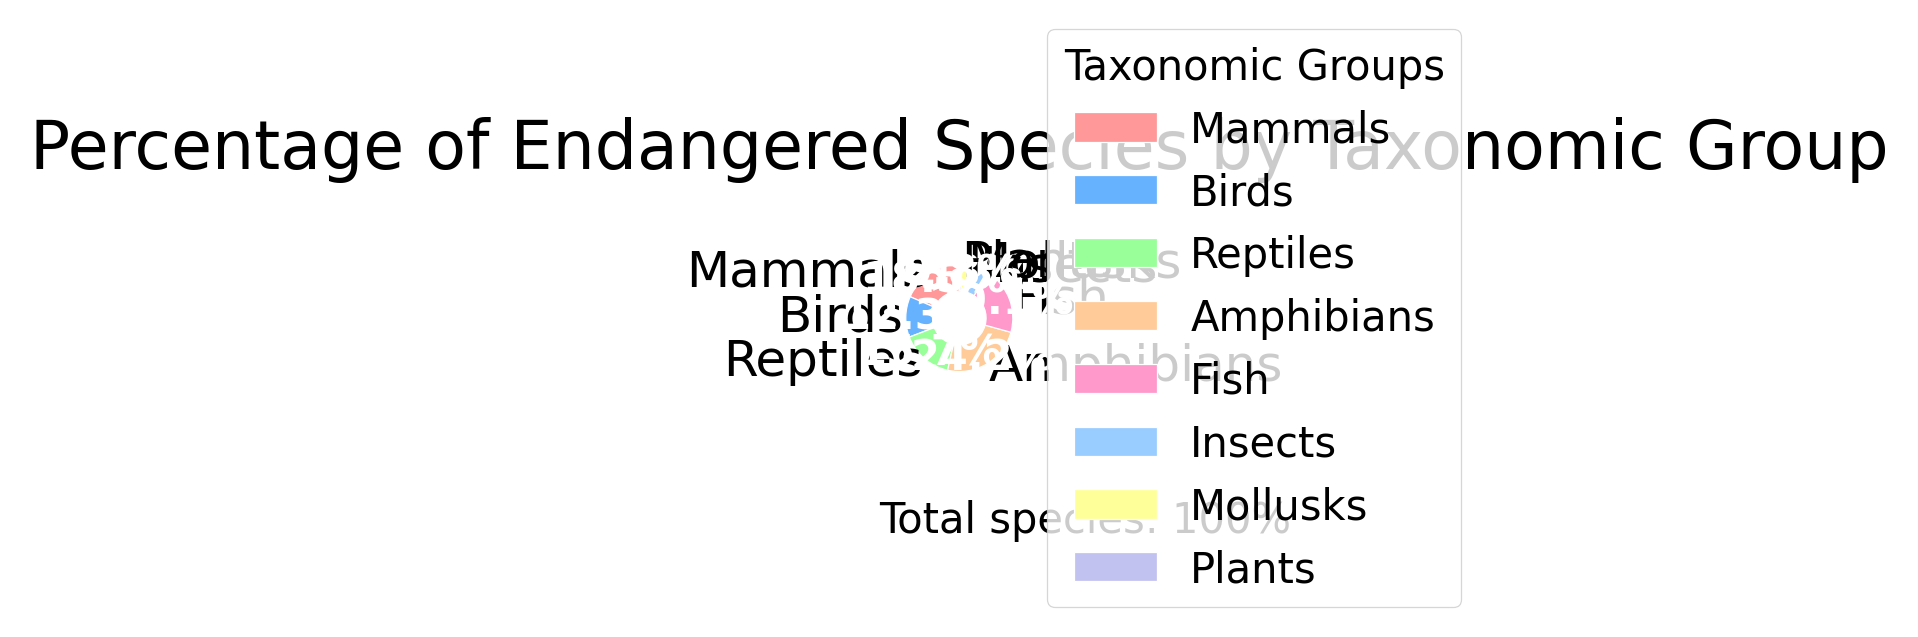Which taxonomic group has the highest percentage of endangered species? By looking at the pie chart, we can see that the taxonomic group with the largest section is labeled "Amphibians" with 24.2%.
Answer: Amphibians What is the combined percentage of endangered species for birds and fish? Birds have 12.3% and fish have 20.1%. Adding these percentages together: 12.3 + 20.1 = 32.4%.
Answer: 32.4% Are there more endangered species in mammals or reptiles? The pie chart shows mammals at 18.5% and reptiles at 15.7%. Therefore, mammals have a higher percentage.
Answer: Mammals Which taxonomic group has the smallest percentage of endangered species and what is that percentage? Observing the smallest slice of the pie chart, the group "Plants" is specified with a percentage of 0.8%.
Answer: Plants with 0.8% Is the percentage of endangered insects higher or lower than 10%? The chart shows that insects comprise 5.6%, which is lower than 10%.
Answer: Lower What is the percentage difference between amphibians and mollusks? Amphibians have 24.2% and mollusks have 2.8%. The difference is calculated as 24.2 - 2.8 = 21.4%.
Answer: 21.4% What is the average percentage of endangered species across all taxonomic groups? To find the average, sum up all the percentages and divide by the number of groups. The total is 18.5 + 12.3 + 15.7 + 24.2 + 20.1 + 5.6 + 2.8 + 0.8 = 100%. Dividing 100 by 8 groups equals 12.5%.
Answer: 12.5% Which color corresponds to the group with the second-highest percentage of endangered species? The second-largest section in the chart belongs to fish, with 20.1%. Fish is displayed in a greenish color.
Answer: Greenish Are there any groups with a percentage below 5%? If so, which ones? In the pie chart, both insects at 5.6% and mollusks at 2.8% are listed. Insects slightly exceed 5%, so only mollusks are below 5%.
Answer: Mollusks By how much does the percentage of endangered mammals exceed that of birds? Mammals are listed at 18.5% and birds at 12.3%. The difference is calculated as 18.5 - 12.3 = 6.2%.
Answer: 6.2% 